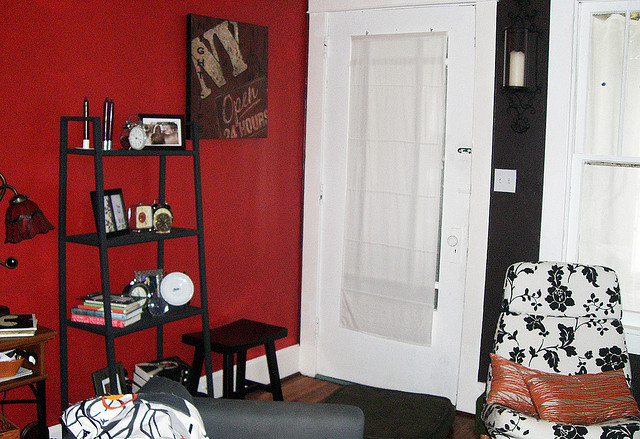Extract all visible text content from this image. NY 